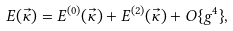Convert formula to latex. <formula><loc_0><loc_0><loc_500><loc_500>E ( \vec { \kappa } ) = E ^ { ( 0 ) } ( \vec { \kappa } ) + E ^ { ( 2 ) } ( \vec { \kappa } ) + O \{ g ^ { 4 } \} ,</formula> 